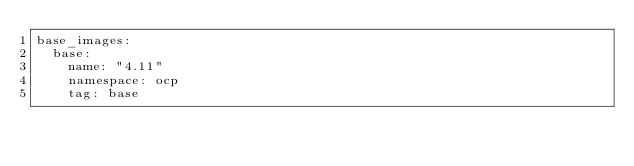Convert code to text. <code><loc_0><loc_0><loc_500><loc_500><_YAML_>base_images:
  base:
    name: "4.11"
    namespace: ocp
    tag: base</code> 